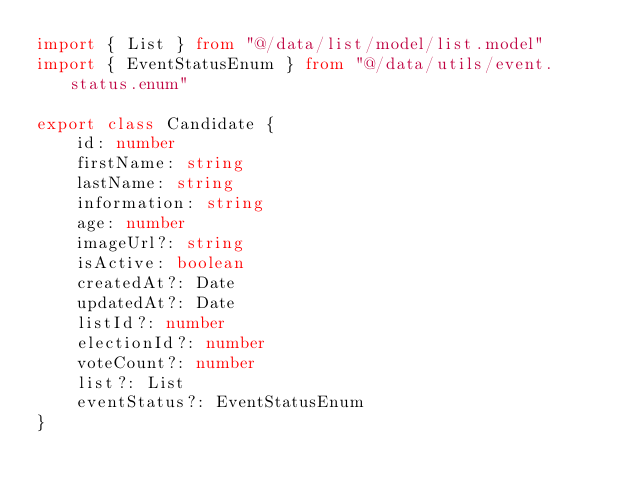<code> <loc_0><loc_0><loc_500><loc_500><_TypeScript_>import { List } from "@/data/list/model/list.model"
import { EventStatusEnum } from "@/data/utils/event.status.enum"

export class Candidate {
    id: number
    firstName: string
    lastName: string
    information: string
    age: number
    imageUrl?: string
    isActive: boolean
    createdAt?: Date
    updatedAt?: Date
    listId?: number
    electionId?: number
    voteCount?: number
    list?: List
    eventStatus?: EventStatusEnum
}
</code> 